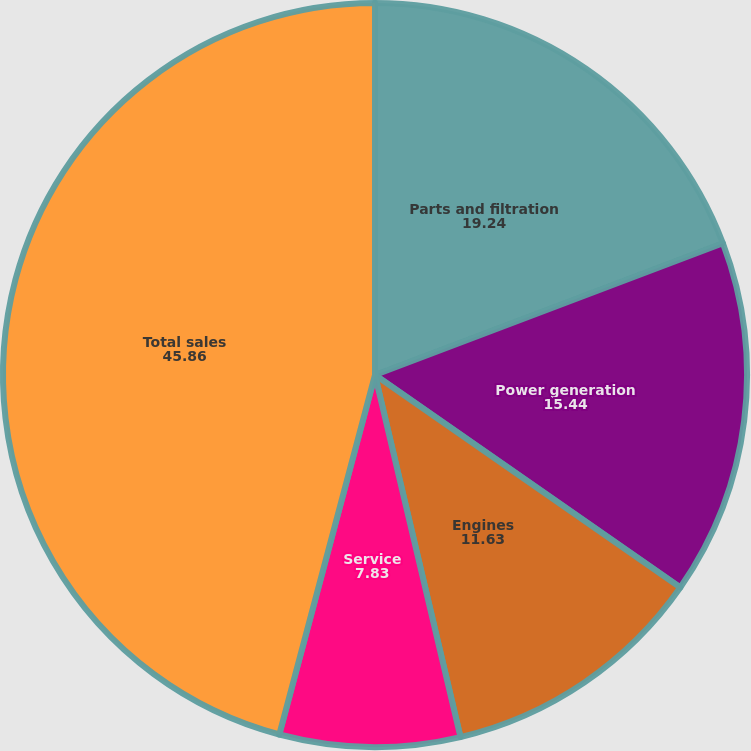Convert chart to OTSL. <chart><loc_0><loc_0><loc_500><loc_500><pie_chart><fcel>Parts and filtration<fcel>Power generation<fcel>Engines<fcel>Service<fcel>Total sales<nl><fcel>19.24%<fcel>15.44%<fcel>11.63%<fcel>7.83%<fcel>45.86%<nl></chart> 